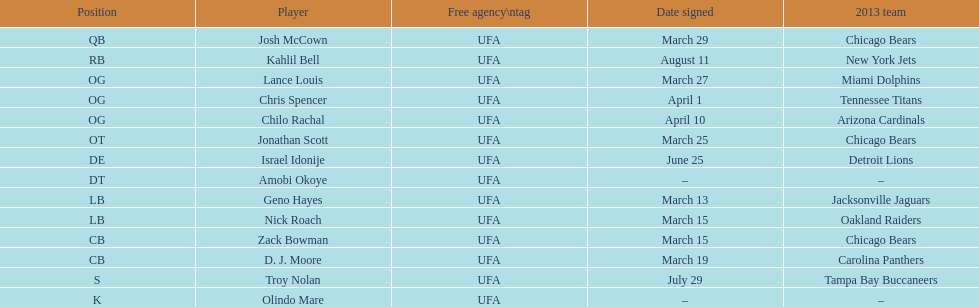Can you provide a last name that doubles as a first name and starts with the letter "n"? Troy Nolan. 